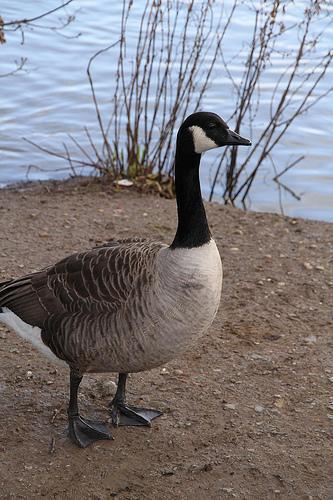How many legs does the animal have?
Give a very brief answer. 2. How many birds are in the dirt?
Give a very brief answer. 1. How many geese are in the photo?
Give a very brief answer. 1. 